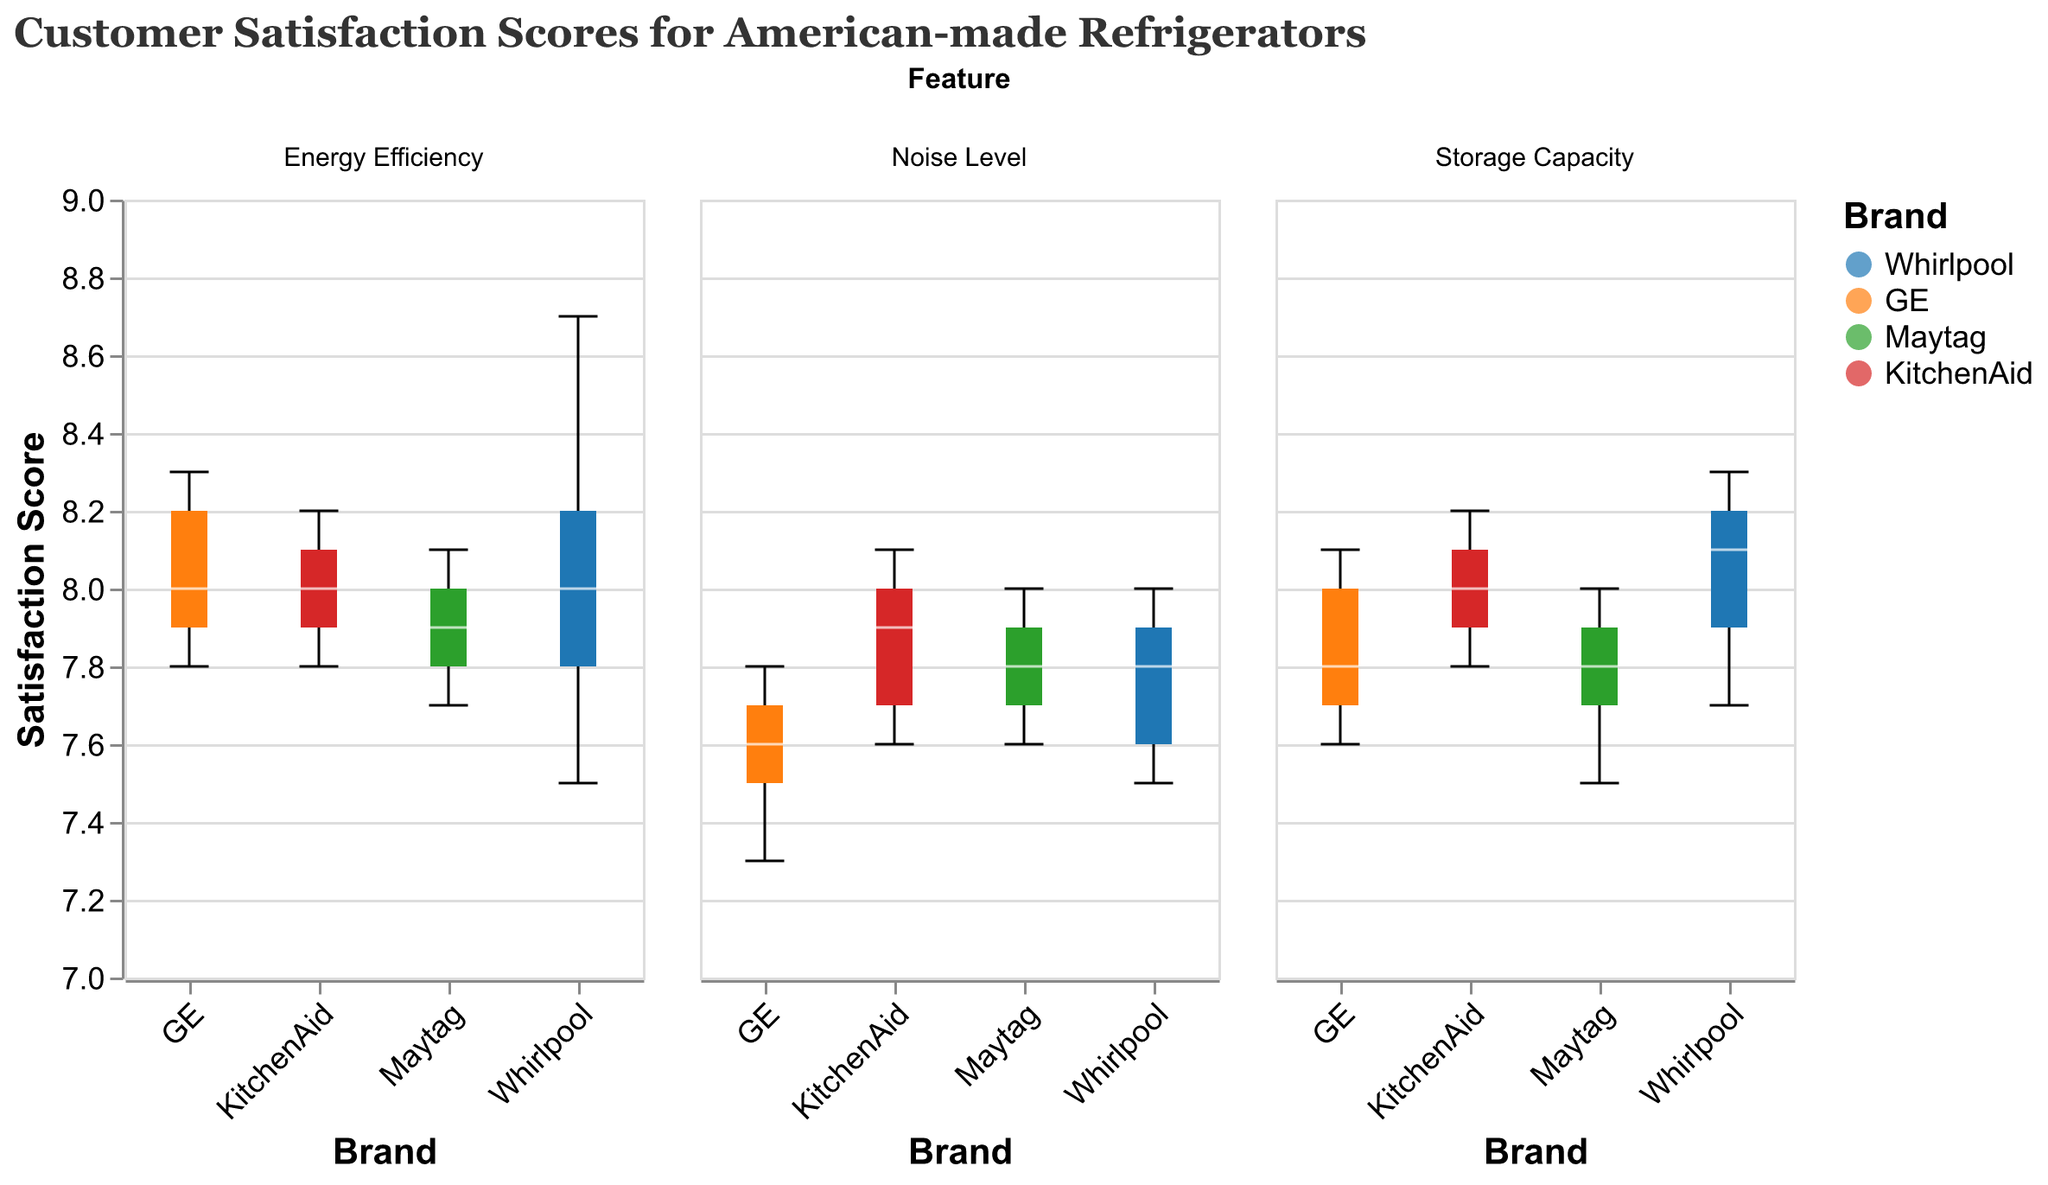What is the title of the plot? The title of the plot is often displayed at the top of the figure and summarizes the data being visualized. In this case, it reads: "Customer Satisfaction Scores for American-made Refrigerators"
Answer: Customer Satisfaction Scores for American-made Refrigerators What is the y-axis measuring in the plot? The y-axis label typically indicates the variable being measured, which in this plot is "Satisfaction Score". This axis measures customer satisfaction scores on a scale from 7 to 9
Answer: Satisfaction Score Which brand has the highest median satisfaction for Energy Efficiency? For Energy Efficiency, compare the median line within each boxplot across different brands. The top median line belongs to GE, which is the highest among the brands.
Answer: GE How do the median customer satisfaction scores for Storage Capacity compare between Whirlpool and KitchenAid? Look at the median lines within the boxplots for Whirlpool and KitchenAid under Storage Capacity. KitchenAid has a slightly higher median satisfaction score compared to Whirlpool
Answer: KitchenAid has a higher median Which feature has the highest variability in customer satisfaction for GE refrigerators? High variability in a boxplot is indicated by a larger interquartile range and longer whiskers. Comparing the three features (Energy Efficiency, Storage Capacity, Noise Level) for GE, Noise Level shows the highest variability
Answer: Noise Level Is the overall satisfaction for Energy Efficiency generally higher than for Noise Level across all brands? Compare the overall distribution of satisfaction scores (spread of boxplots) of Energy Efficiency and Noise Level. Energy Efficiency shows higher median and smaller spread of scores overall across all brands than Noise Level
Answer: Yes What is the median satisfaction score for Maytag's Noise Level? To find the median, look at the white line inside the boxplot for Maytag under the Noise Level feature. The median satisfaction score for Maytag is approximately 7.8
Answer: 7.8 Which feature set shows the least variation in customer satisfaction for KitchenAid? Identify the feature set with the shortest box and whiskers range for KitchenAid. For KitchenAid, Storage Capacity shows the least variation
Answer: Storage Capacity For Whirlpool, which feature has the smallest interquartile range in satisfaction? The interquartile range is the difference between the first and third quartile. Look at the widths of the boxes for Whirlpool in all three categories. Energy Efficiency has the smallest interquartile range
Answer: Energy Efficiency Which brand has the lowest satisfaction scores for Storage Capacity? For Storage Capacity, compare the lower whiskers of the boxplots for all brands. GE has the lowest whisker, indicating the lowest satisfaction scores in this category
Answer: GE 